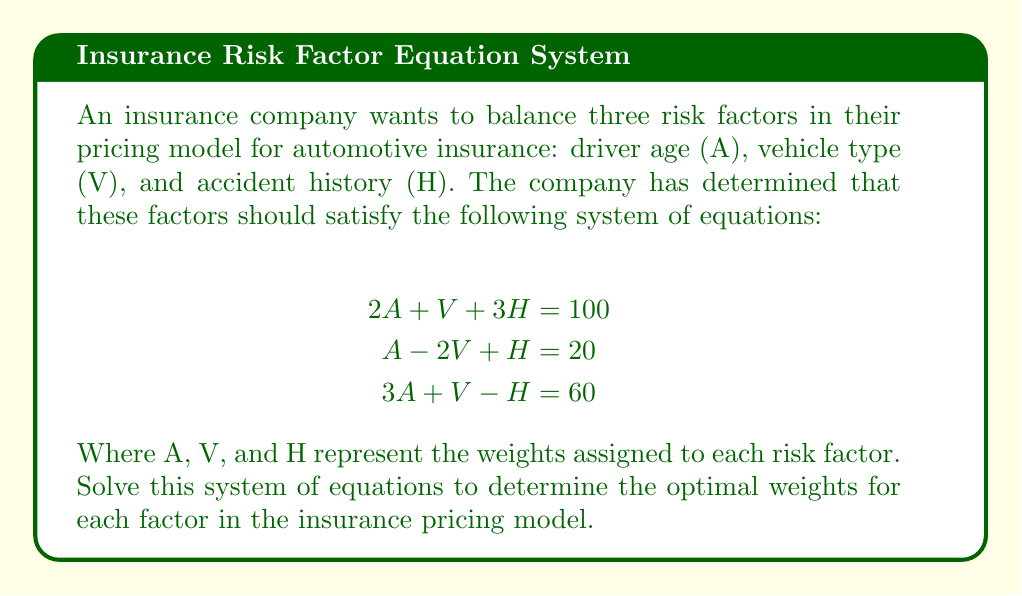Can you answer this question? To solve this system of equations, we'll use the Gaussian elimination method:

1) First, write the augmented matrix:

   $$\begin{bmatrix}
   2 & 1 & 3 & | & 100 \\
   1 & -2 & 1 & | & 20 \\
   3 & 1 & -1 & | & 60
   \end{bmatrix}$$

2) Multiply the first row by -1/2 and add it to the second row:

   $$\begin{bmatrix}
   2 & 1 & 3 & | & 100 \\
   0 & -2.5 & -0.5 & | & -30 \\
   3 & 1 & -1 & | & 60
   \end{bmatrix}$$

3) Multiply the first row by -3/2 and add it to the third row:

   $$\begin{bmatrix}
   2 & 1 & 3 & | & 100 \\
   0 & -2.5 & -0.5 & | & -30 \\
   0 & -0.5 & -5.5 & | & -90
   \end{bmatrix}$$

4) Multiply the second row by 1/5 and add it to the third row:

   $$\begin{bmatrix}
   2 & 1 & 3 & | & 100 \\
   0 & -2.5 & -0.5 & | & -30 \\
   0 & 0 & -5.6 & | & -96
   \end{bmatrix}$$

5) Now we have an upper triangular matrix. Solve for H:

   $-5.6H = -96$
   $H = 17.14285714$

6) Substitute H into the second equation:

   $-2.5V - 0.5(17.14285714) = -30$
   $-2.5V = -21.42857143$
   $V = 8.57142857$

7) Finally, substitute H and V into the first equation:

   $2A + 8.57142857 + 3(17.14285714) = 100$
   $2A = 39.28571429$
   $A = 19.64285714$

8) Round the results to two decimal places for practical use in the insurance model.
Answer: $A = 19.64$, $V = 8.57$, $H = 17.14$ 